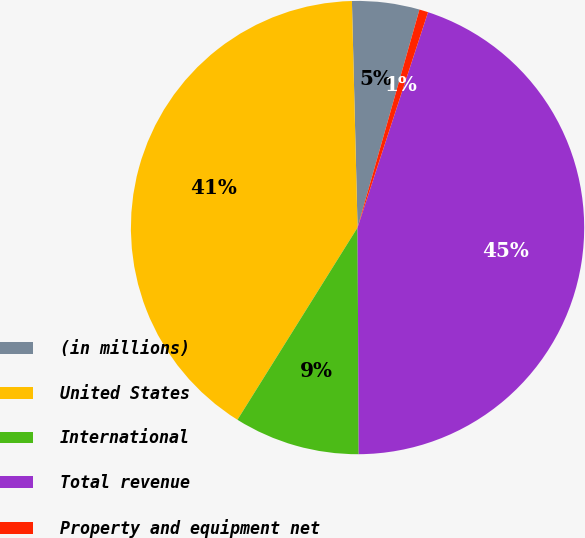<chart> <loc_0><loc_0><loc_500><loc_500><pie_chart><fcel>(in millions)<fcel>United States<fcel>International<fcel>Total revenue<fcel>Property and equipment net<nl><fcel>4.8%<fcel>40.72%<fcel>8.97%<fcel>44.89%<fcel>0.63%<nl></chart> 